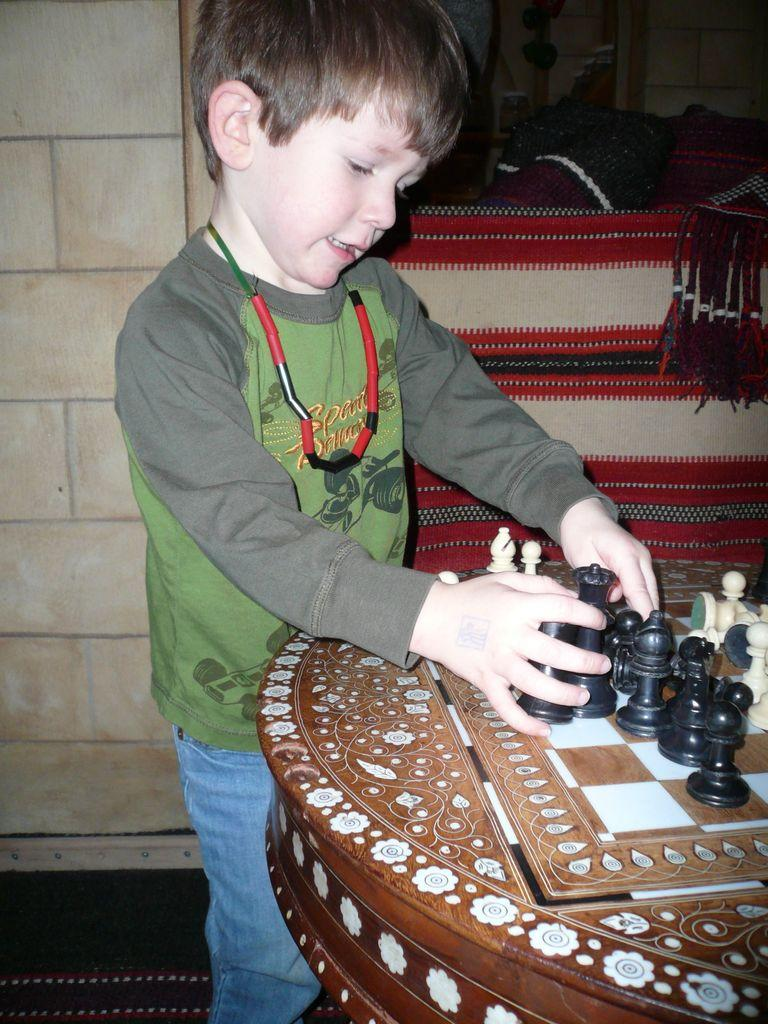Who is the main subject in the image? There is a boy in the image. What is the boy doing in the image? The boy is playing with a chess board. Where is the chess board located in the image? The chess board is placed on a table. What type of milk is being poured into the chess board in the image? There is no milk present in the image, and the chess board is not being used for pouring any liquid. 